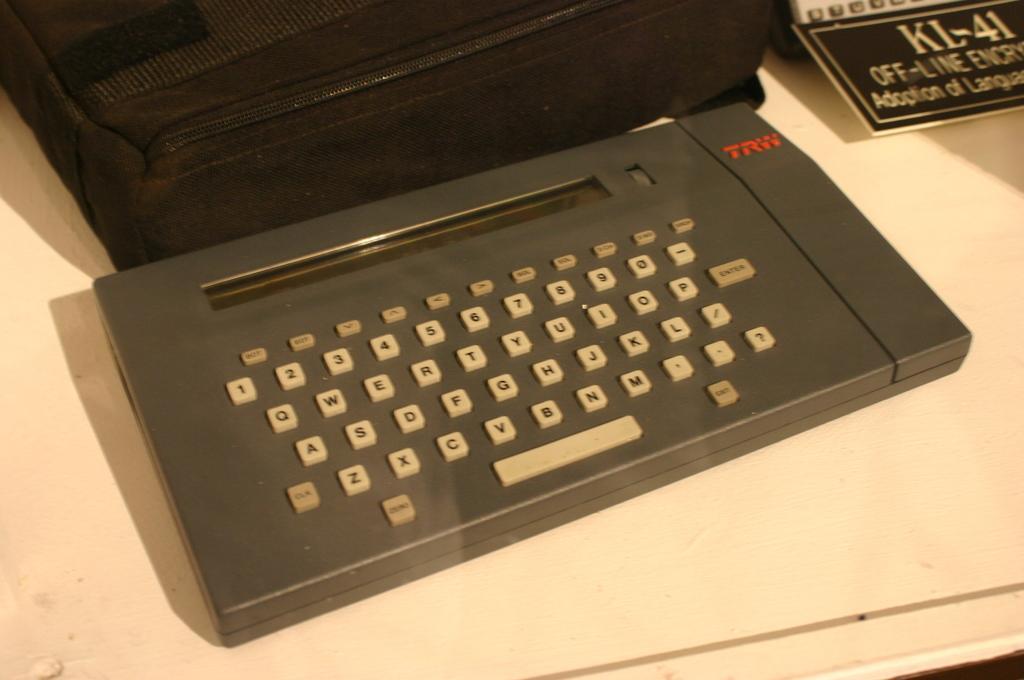Could you give a brief overview of what you see in this image? In the picture we can see a white color desk on it we can see a key board with buttons to it and behind it we can see a bag which is black in color and beside it we can see a board with some information in it. 